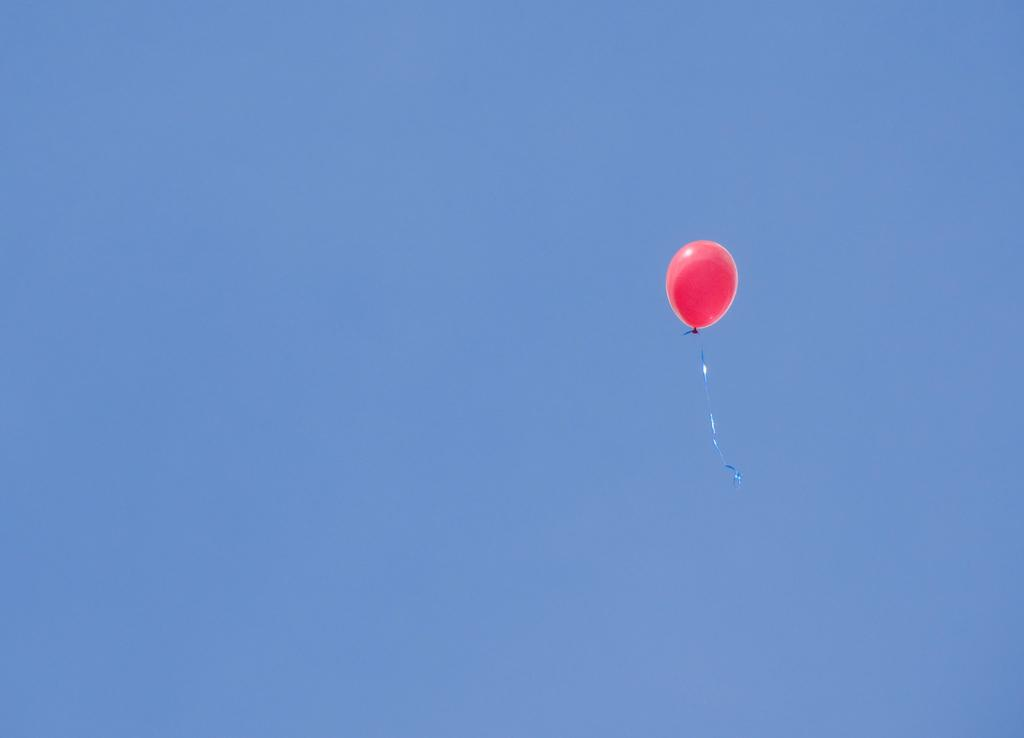What is the color of the sky in the image? The sky in the image is blue. What object is present in the image that is not a part of the sky? There is a pink balloon in the image. What is the balloon doing in the image? The balloon is flying in the air. What is attached to the balloon? The balloon has a blue color ribbon attached to it. Can you see any rifles being used in the image? No, there are no rifles present in the image. Are there any birds talking to each other in the image? There are no birds or any form of communication between them in the image. 